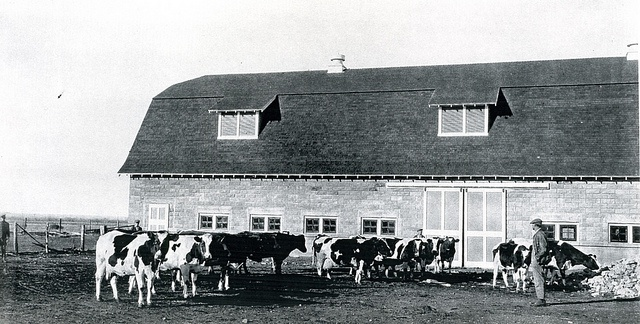Describe the objects in this image and their specific colors. I can see cow in white, black, gray, and darkgray tones, cow in white, black, lightgray, darkgray, and gray tones, cow in white, black, gray, and darkgray tones, cow in white, black, gray, and darkgray tones, and cow in white, black, gray, lightgray, and darkgray tones in this image. 